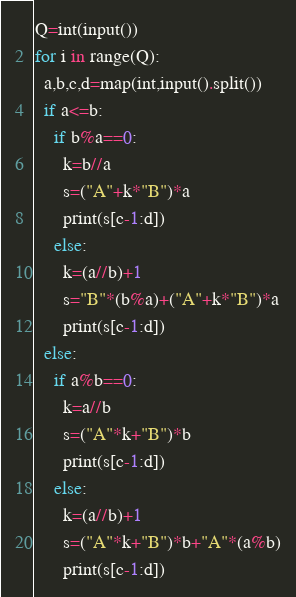<code> <loc_0><loc_0><loc_500><loc_500><_Python_>Q=int(input())
for i in range(Q):
  a,b,c,d=map(int,input().split())
  if a<=b:
    if b%a==0:
      k=b//a
      s=("A"+k*"B")*a
      print(s[c-1:d])
    else:
      k=(a//b)+1
      s="B"*(b%a)+("A"+k*"B")*a
      print(s[c-1:d])
  else:
    if a%b==0:
      k=a//b
      s=("A"*k+"B")*b
      print(s[c-1:d])
    else:
      k=(a//b)+1
      s=("A"*k+"B")*b+"A"*(a%b)
      print(s[c-1:d])</code> 